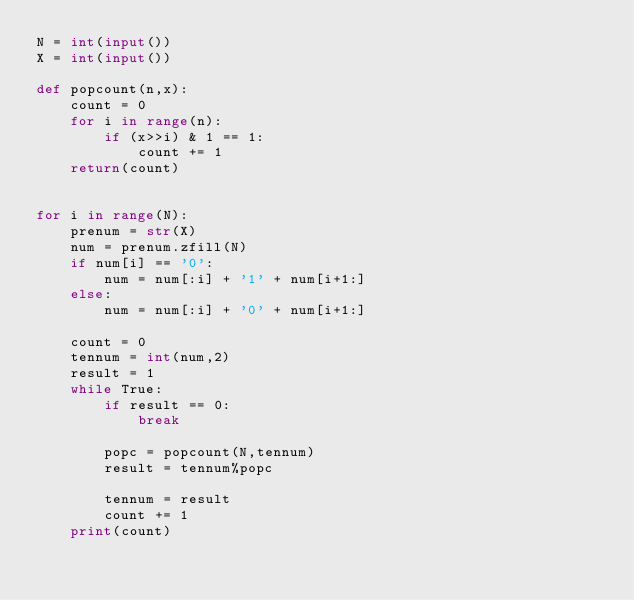<code> <loc_0><loc_0><loc_500><loc_500><_Python_>N = int(input())
X = int(input())

def popcount(n,x):
    count = 0
    for i in range(n):
        if (x>>i) & 1 == 1:
            count += 1
    return(count)


for i in range(N):
    prenum = str(X)
    num = prenum.zfill(N)
    if num[i] == '0':
        num = num[:i] + '1' + num[i+1:]
    else:
        num = num[:i] + '0' + num[i+1:]
    
    count = 0
    tennum = int(num,2)
    result = 1
    while True:
        if result == 0:
            break
        
        popc = popcount(N,tennum)
        result = tennum%popc
        
        tennum = result
        count += 1
    print(count)</code> 